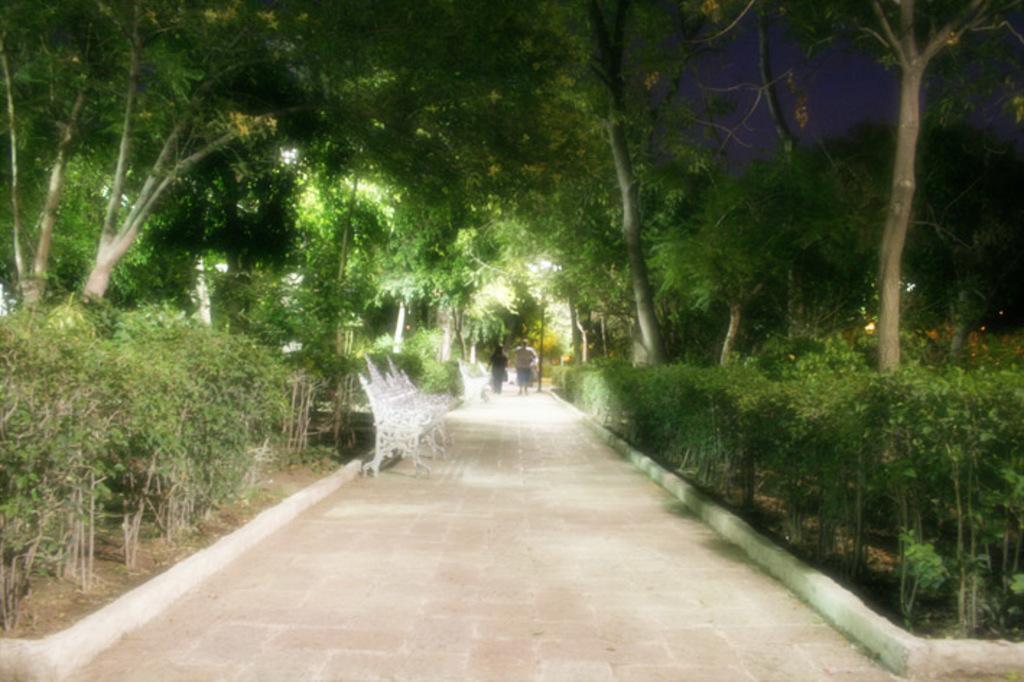Could you give a brief overview of what you see in this image? In this image we can see a park, there is a bench, some plants and trees, and two persons walking on the way, and we can see the sky. 